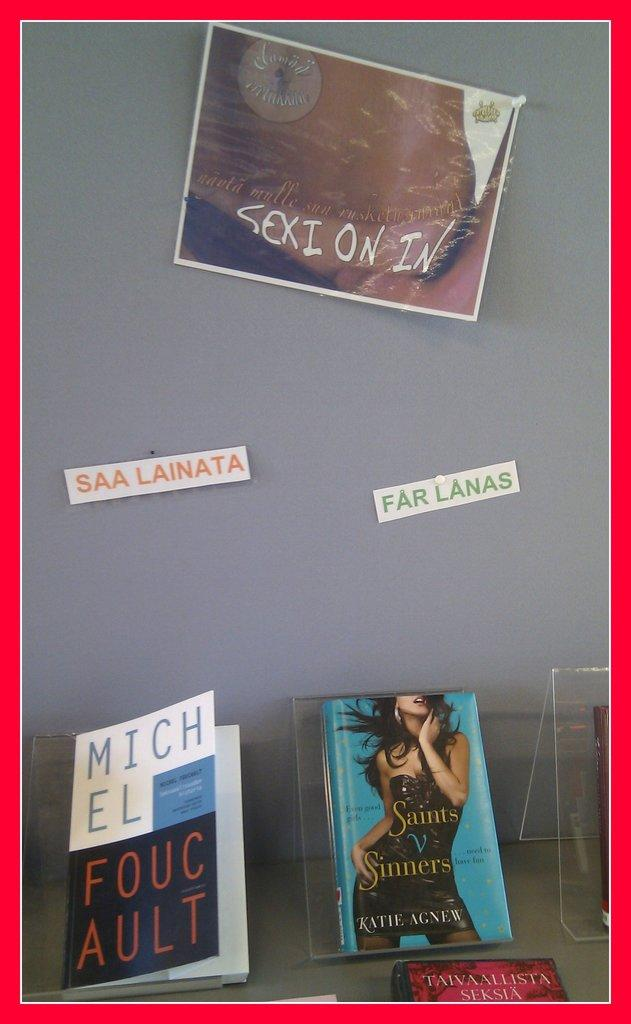<image>
Give a short and clear explanation of the subsequent image. a book that is by the author michel foucault 